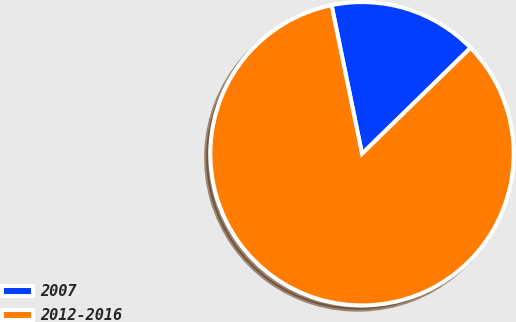Convert chart to OTSL. <chart><loc_0><loc_0><loc_500><loc_500><pie_chart><fcel>2007<fcel>2012-2016<nl><fcel>15.91%<fcel>84.09%<nl></chart> 